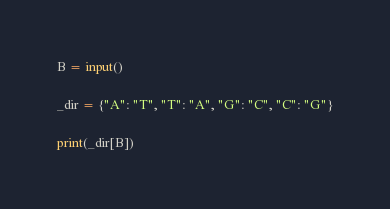<code> <loc_0><loc_0><loc_500><loc_500><_Python_>B = input()

_dir = {"A": "T", "T": "A", "G": "C", "C": "G"}

print(_dir[B])</code> 